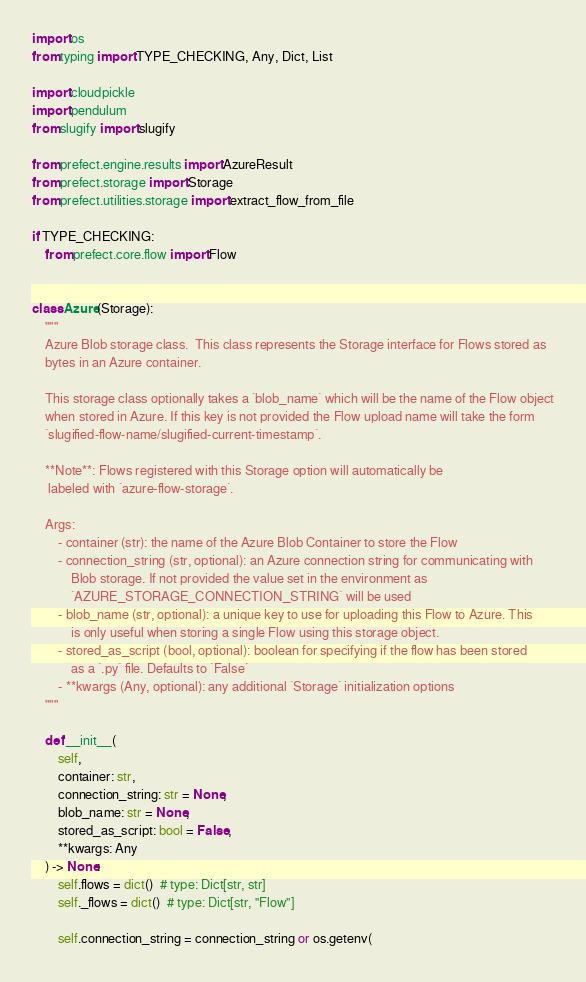Convert code to text. <code><loc_0><loc_0><loc_500><loc_500><_Python_>import os
from typing import TYPE_CHECKING, Any, Dict, List

import cloudpickle
import pendulum
from slugify import slugify

from prefect.engine.results import AzureResult
from prefect.storage import Storage
from prefect.utilities.storage import extract_flow_from_file

if TYPE_CHECKING:
    from prefect.core.flow import Flow


class Azure(Storage):
    """
    Azure Blob storage class.  This class represents the Storage interface for Flows stored as
    bytes in an Azure container.

    This storage class optionally takes a `blob_name` which will be the name of the Flow object
    when stored in Azure. If this key is not provided the Flow upload name will take the form
    `slugified-flow-name/slugified-current-timestamp`.

    **Note**: Flows registered with this Storage option will automatically be
     labeled with `azure-flow-storage`.

    Args:
        - container (str): the name of the Azure Blob Container to store the Flow
        - connection_string (str, optional): an Azure connection string for communicating with
            Blob storage. If not provided the value set in the environment as
            `AZURE_STORAGE_CONNECTION_STRING` will be used
        - blob_name (str, optional): a unique key to use for uploading this Flow to Azure. This
            is only useful when storing a single Flow using this storage object.
        - stored_as_script (bool, optional): boolean for specifying if the flow has been stored
            as a `.py` file. Defaults to `False`
        - **kwargs (Any, optional): any additional `Storage` initialization options
    """

    def __init__(
        self,
        container: str,
        connection_string: str = None,
        blob_name: str = None,
        stored_as_script: bool = False,
        **kwargs: Any
    ) -> None:
        self.flows = dict()  # type: Dict[str, str]
        self._flows = dict()  # type: Dict[str, "Flow"]

        self.connection_string = connection_string or os.getenv(</code> 